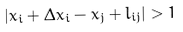<formula> <loc_0><loc_0><loc_500><loc_500>\left | x _ { i } + \Delta x _ { i } - x _ { j } + l _ { i j } \right | > 1</formula> 